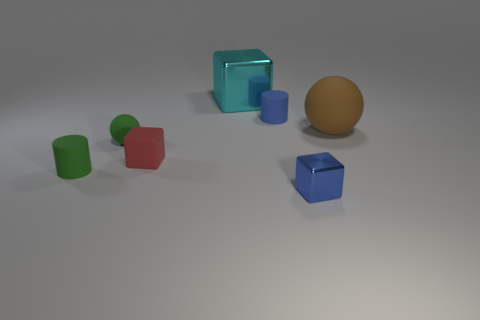Subtract all tiny blocks. How many blocks are left? 1 Add 2 large blue spheres. How many objects exist? 9 Subtract all cylinders. How many objects are left? 5 Subtract all blocks. Subtract all large cyan blocks. How many objects are left? 3 Add 7 blue things. How many blue things are left? 9 Add 4 big matte objects. How many big matte objects exist? 5 Subtract 1 brown spheres. How many objects are left? 6 Subtract all gray blocks. Subtract all gray cylinders. How many blocks are left? 3 